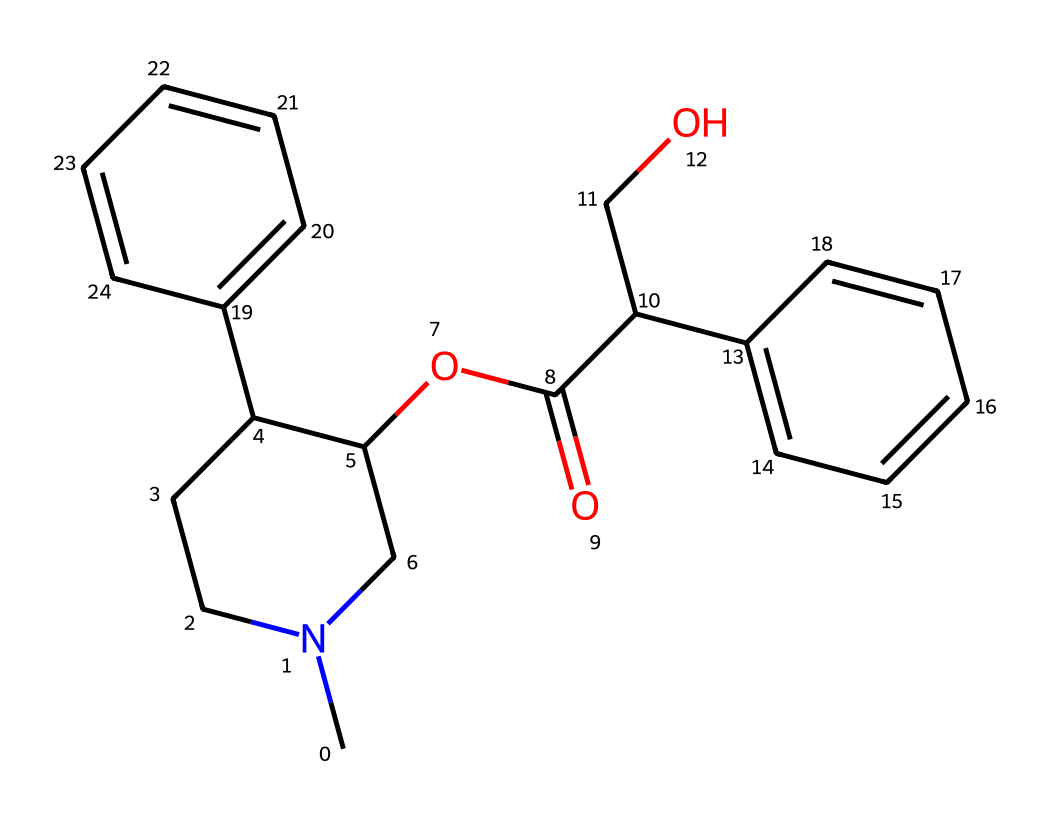What is the molecular formula of atropine? The SMILES representation can be decoded to find the atomic composition. By identifying each unique atom and counting, we find that atropine has a molecular formula of C17H23NO3.
Answer: C17H23NO3 How many rings are present in the structure of atropine? In the SMILES representation, we look for digits that indicate ring structures. The numbers 1 and 2 indicate ring closures. There are two rings in the structure.
Answer: 2 What functional groups are present in atropine? The structure contains an ester (C(=O)), a hydroxyl group (C(O)), and the nitrogen suggests it is an amine. All these functional groups contribute to the reactivity of the compound.
Answer: ester, hydroxyl, amine What type of stereochemistry might atropine exhibit? The presence of chirality can be inferred from the presence of multiple groups around a carbon atom, particularly where it has four different substituents. This implies atropine likely exhibits stereoisomerism.
Answer: stereoisomerism Which part of atropine is responsible for its pharmacological effects? The nitrogen-containing structure (the tertiary amine) commonly found in alkaloids is primarily responsible for the pharmacological effects such as dilation of pupils, which functions as a muscarinic antagonist.
Answer: nitrogen What type of plants commonly contain atropine? Atropine is derived primarily from specific plants like Atropa belladonna, also known as deadly nightshade, and several other Solanaceae family members.
Answer: Solanaceae What is the physiological effect of atropine on the body? Atropine typically functions as an anticholinergic agent, blocking the action of acetylcholine and leading to increased heart rate and pupil dilation among other effects.
Answer: anticholinergic agent 